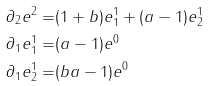Convert formula to latex. <formula><loc_0><loc_0><loc_500><loc_500>\partial _ { 2 } e ^ { 2 } = & ( 1 + b ) e ^ { 1 } _ { 1 } + ( a - 1 ) e ^ { 1 } _ { 2 } \\ \partial _ { 1 } e ^ { 1 } _ { 1 } = & ( a - 1 ) e ^ { 0 } \\ \partial _ { 1 } e ^ { 1 } _ { 2 } = & ( b a - 1 ) e ^ { 0 }</formula> 